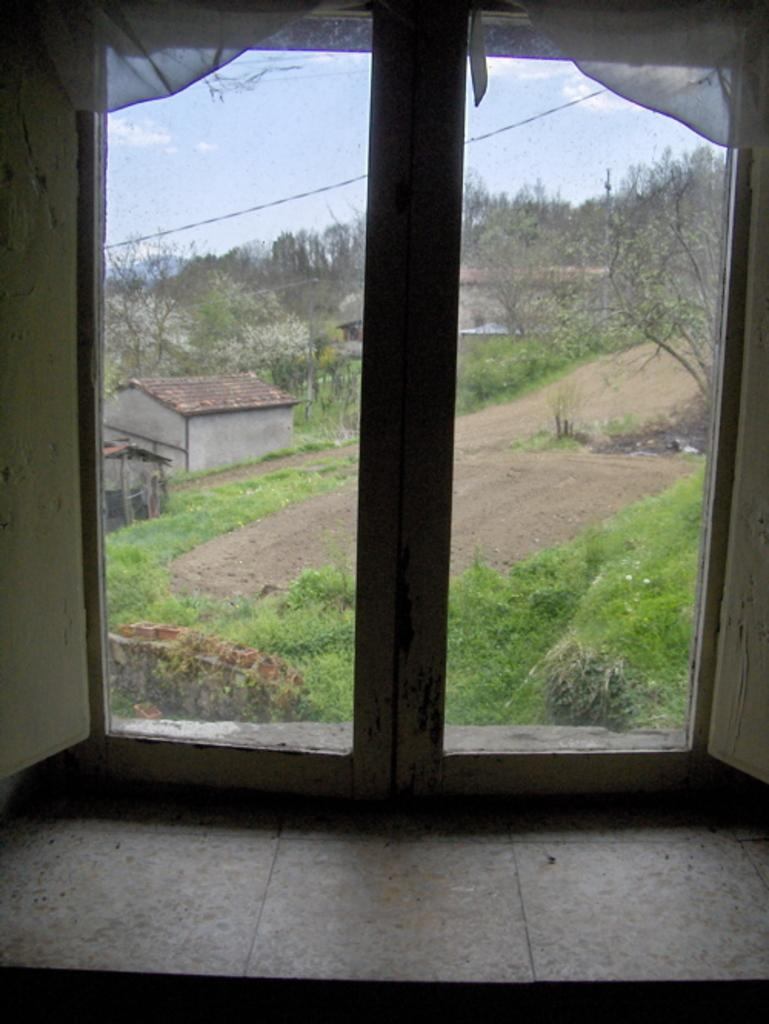What type of structure is depicted in the image? The image appears to be a window with glass doors. What can be seen outside the window? Houses, trees, grass, a road, and the sky are visible through the window. What type of caption is written on the window in the image? There is no caption written on the window in the image. Can you see any fights happening outside the window in the image? There is no fight visible outside the window in the image. 